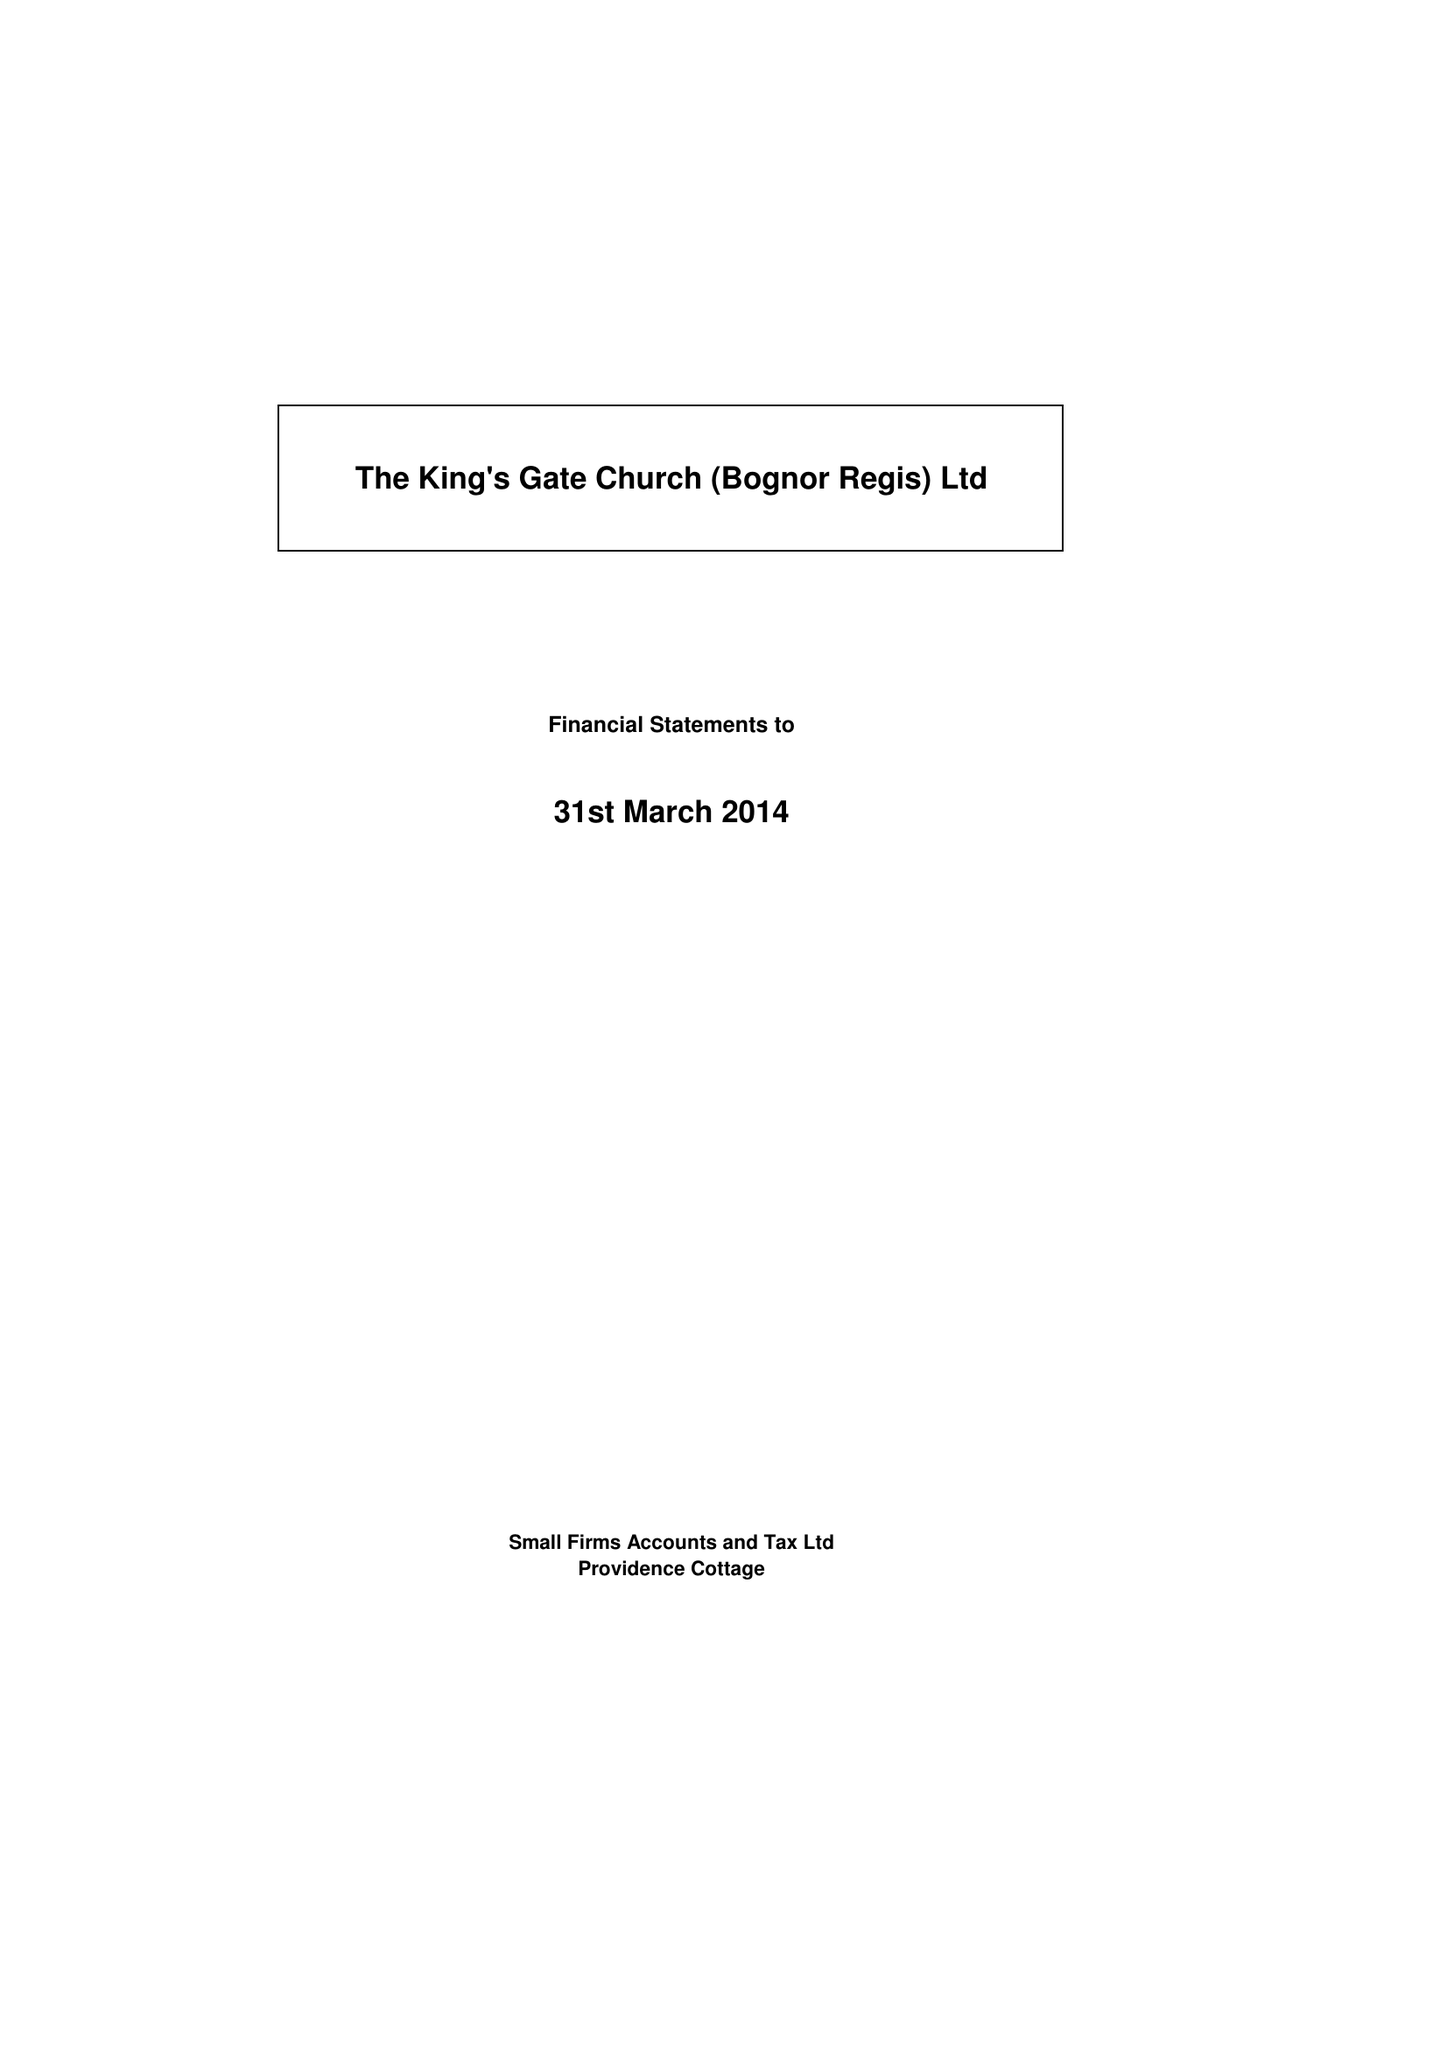What is the value for the charity_number?
Answer the question using a single word or phrase. 1108556 